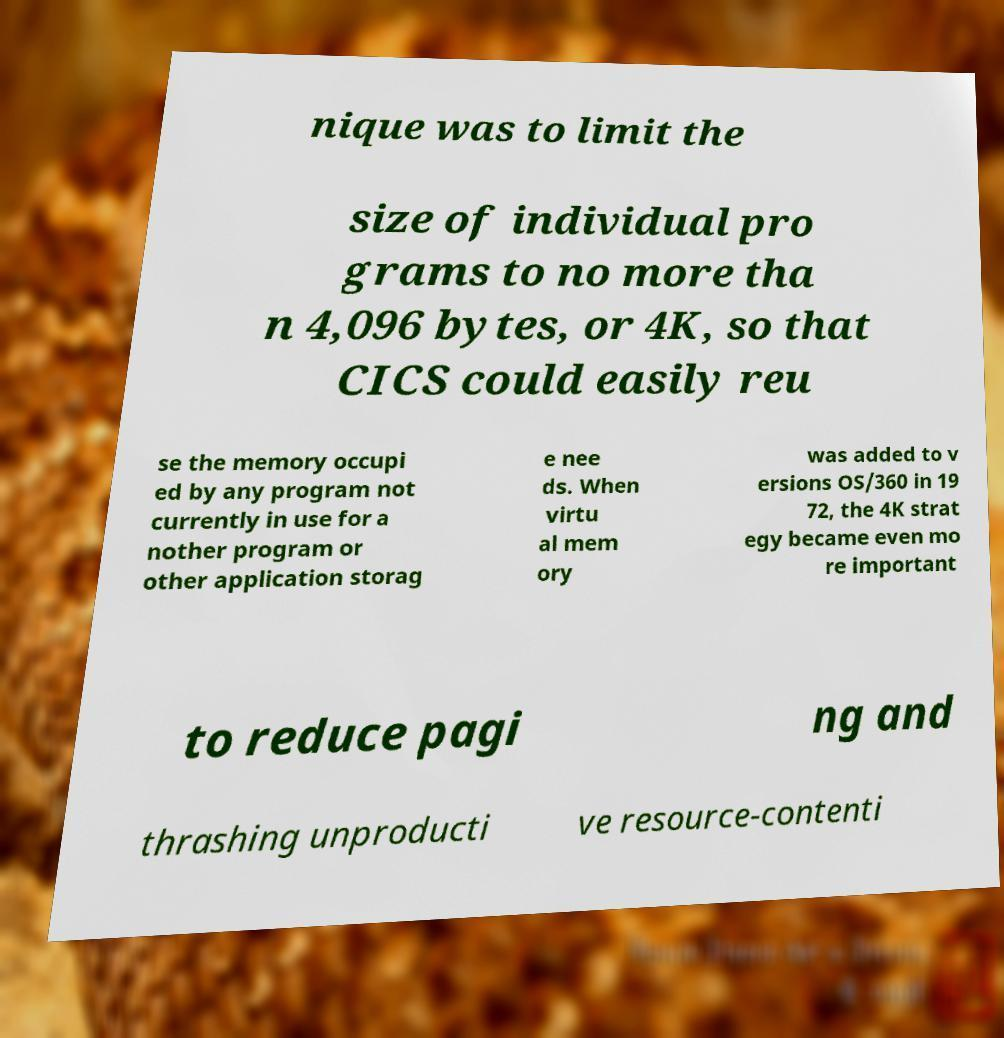What messages or text are displayed in this image? I need them in a readable, typed format. nique was to limit the size of individual pro grams to no more tha n 4,096 bytes, or 4K, so that CICS could easily reu se the memory occupi ed by any program not currently in use for a nother program or other application storag e nee ds. When virtu al mem ory was added to v ersions OS/360 in 19 72, the 4K strat egy became even mo re important to reduce pagi ng and thrashing unproducti ve resource-contenti 